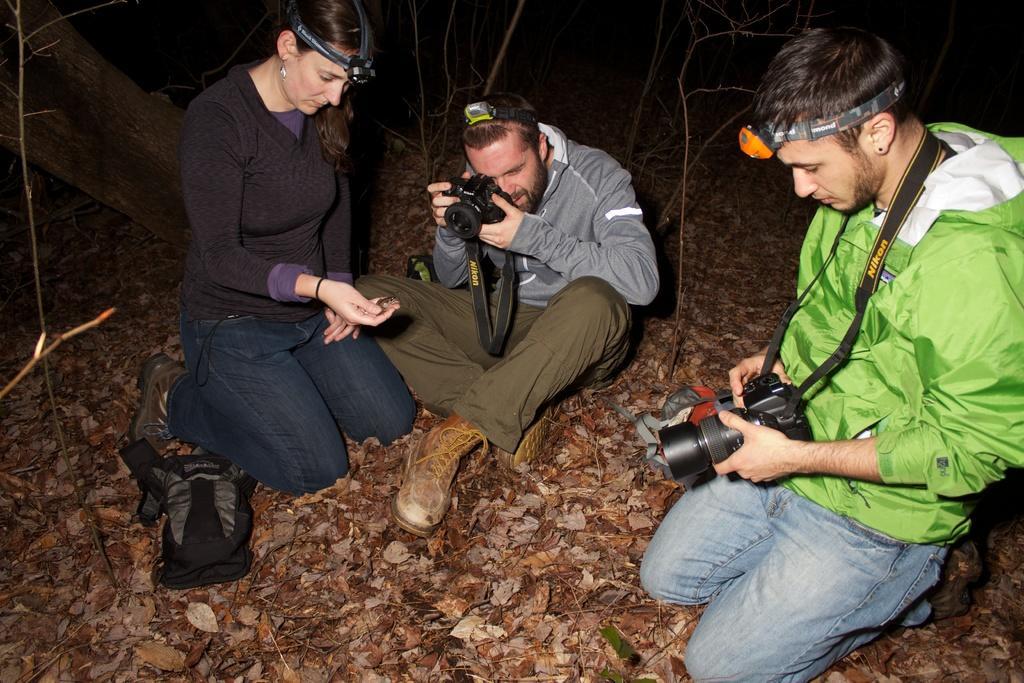In one or two sentences, can you explain what this image depicts? This picture is clicked outside. On the right we can see a person wearing jacket, kneeling on the ground and holding a camera. In the center we can see a man sitting on the ground, holding a camera and seems to be taking pictures. On the left we can see a woman holding an object and kneeling on the ground and we can see the dry leaves lying on the ground and we can see the bag and the dry stems and some other objects. 